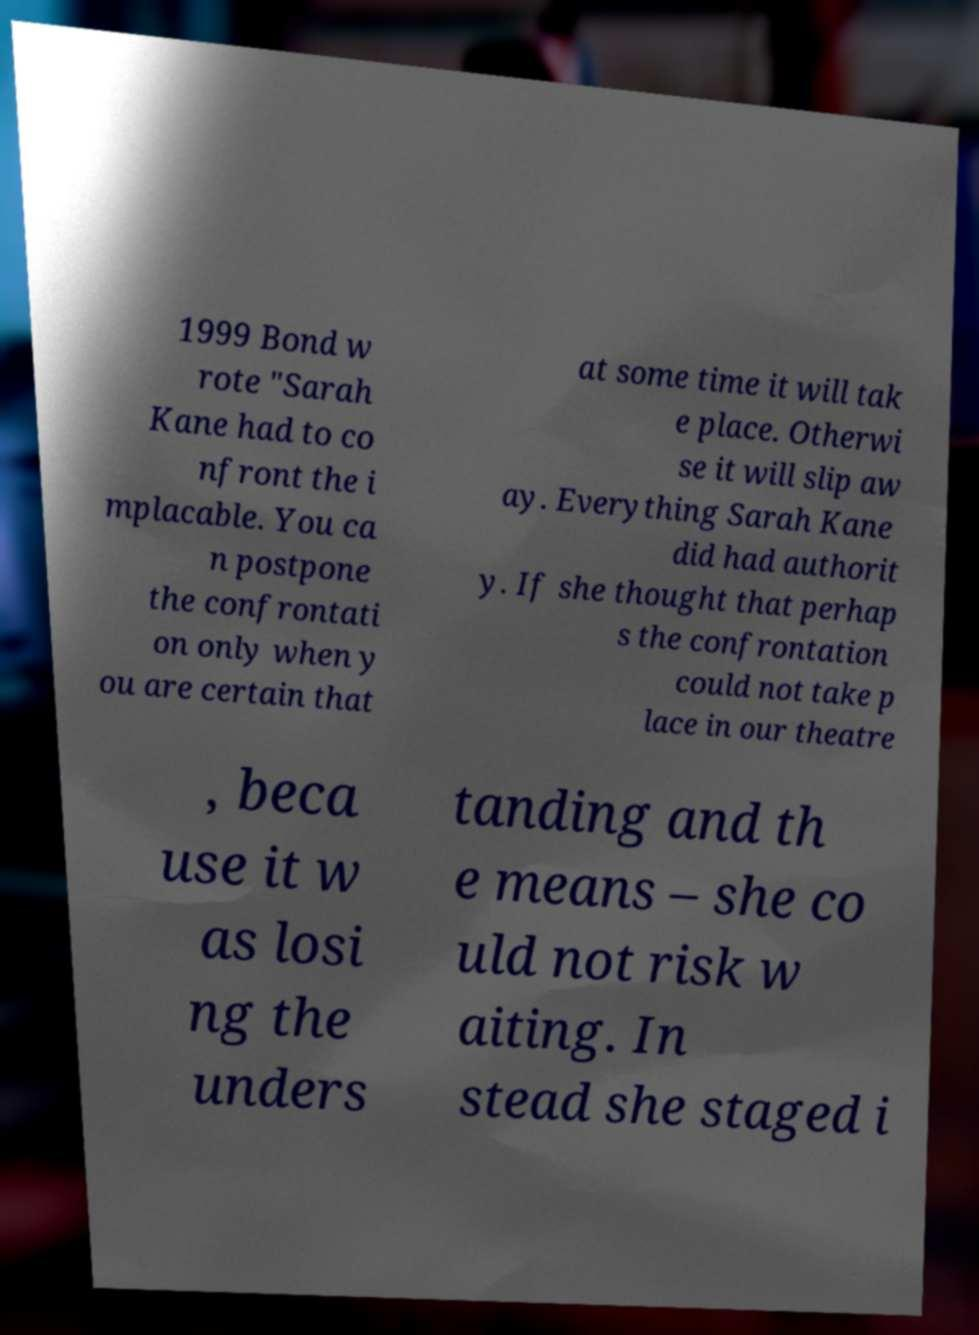Could you extract and type out the text from this image? 1999 Bond w rote "Sarah Kane had to co nfront the i mplacable. You ca n postpone the confrontati on only when y ou are certain that at some time it will tak e place. Otherwi se it will slip aw ay. Everything Sarah Kane did had authorit y. If she thought that perhap s the confrontation could not take p lace in our theatre , beca use it w as losi ng the unders tanding and th e means – she co uld not risk w aiting. In stead she staged i 